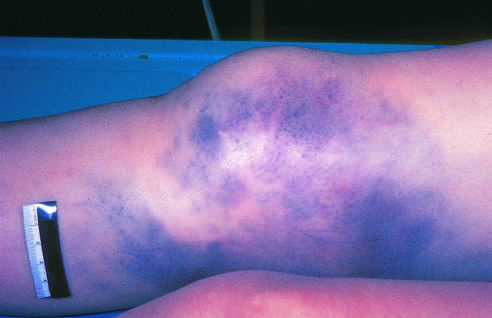what has hemorrhage of subcutaneous vessels produced?
Answer the question using a single word or phrase. Extensive discoloration 